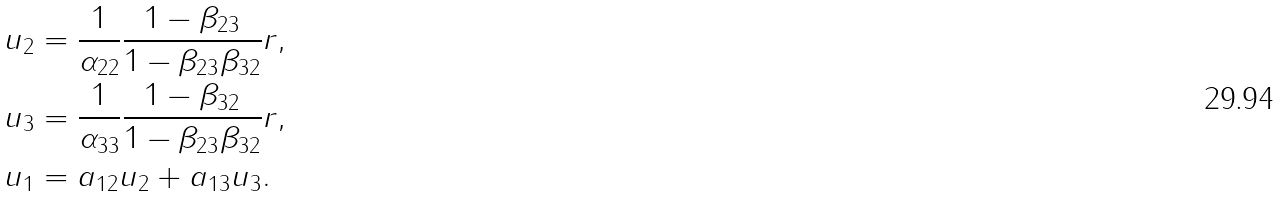Convert formula to latex. <formula><loc_0><loc_0><loc_500><loc_500>u _ { 2 } & = \frac { 1 } { \alpha _ { 2 2 } } \frac { 1 - \beta _ { 2 3 } } { 1 - \beta _ { 2 3 } \beta _ { 3 2 } } r , \\ u _ { 3 } & = \frac { 1 } { \alpha _ { 3 3 } } \frac { 1 - \beta _ { 3 2 } } { 1 - \beta _ { 2 3 } \beta _ { 3 2 } } r , \\ u _ { 1 } & = a _ { 1 2 } u _ { 2 } + a _ { 1 3 } u _ { 3 } .</formula> 